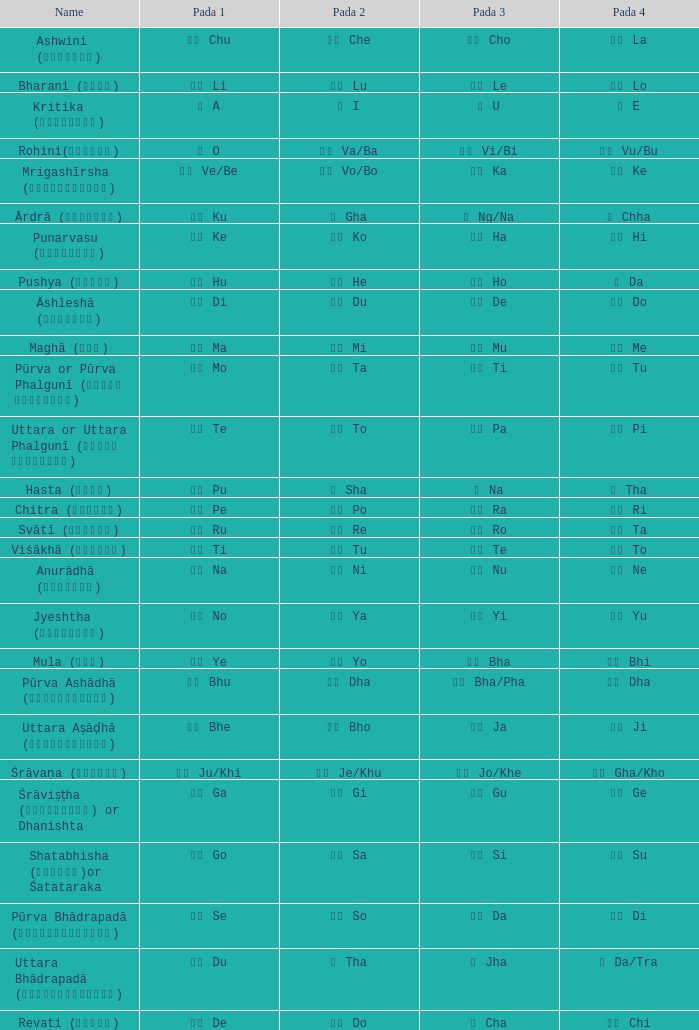What kind of Pada 1 has a Pada 2 of सा sa? गो Go. 